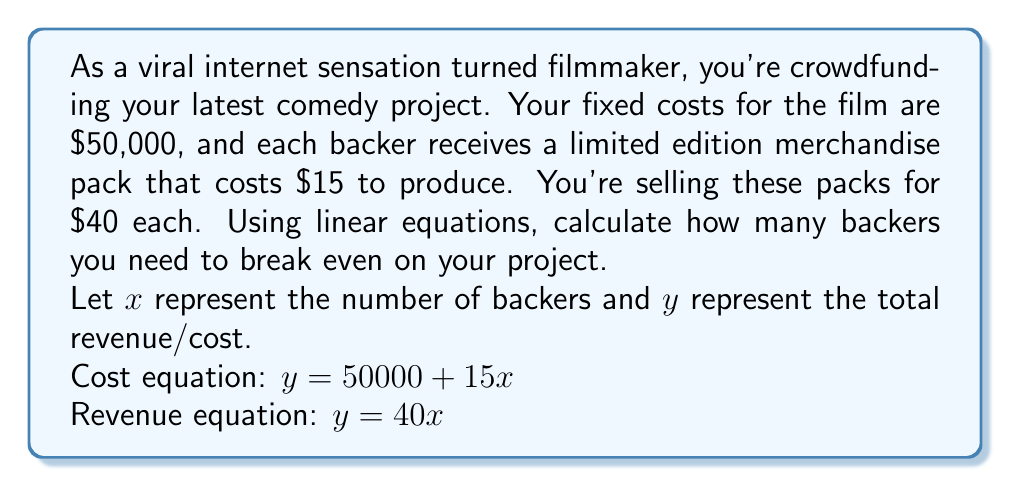Give your solution to this math problem. To find the break-even point, we need to determine where the cost and revenue equations are equal. This is the point where total revenue equals total cost.

1) Set the cost and revenue equations equal to each other:
   $50000 + 15x = 40x$

2) Subtract $15x$ from both sides:
   $50000 = 25x$

3) Divide both sides by 25:
   $\frac{50000}{25} = x$

4) Simplify:
   $2000 = x$

To verify, we can plug this value back into our original equations:

Cost: $y = 50000 + 15(2000) = 50000 + 30000 = 80000$
Revenue: $y = 40(2000) = 80000$

As both equations equal $80,000, this confirms our break-even point.
Answer: You need 2,000 backers to break even on your crowdfunded film project. 